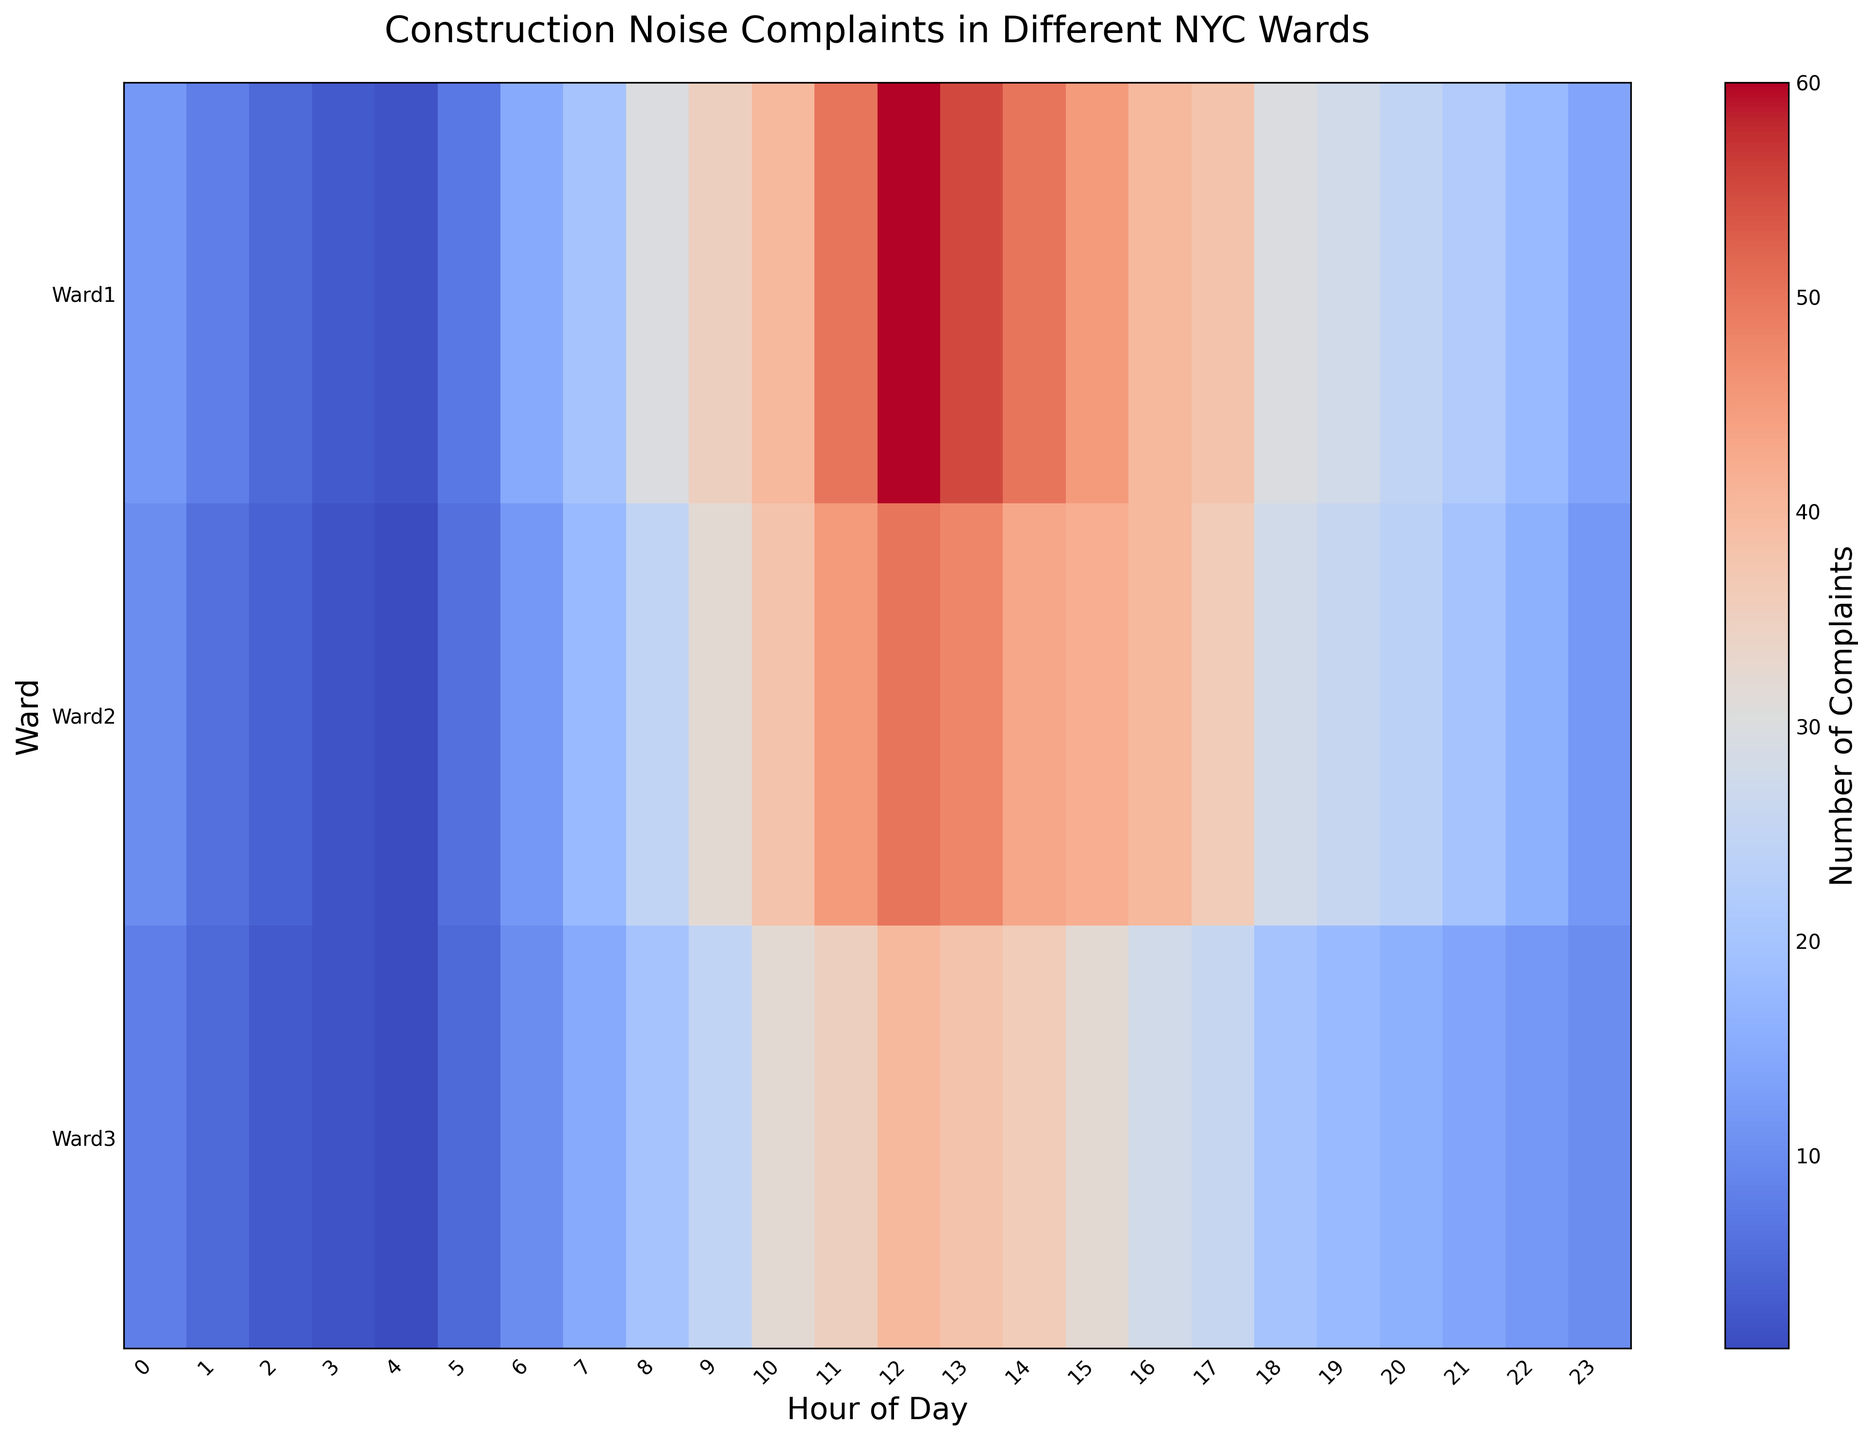What is the total number of complaints in Ward1 during the 8 AM and 9 AM hours? To get the total number of complaints, sum up the complaints at 8 AM and 9 AM for Ward1. These numbers are 30 for 8 AM and 35 for 9 AM. Adding them gives 30 + 35 = 65.
Answer: 65 At which hour does Ward2 observe the peak number of complaints? To find the peak number of complaints for Ward2, we look for the highest value on the heatmap for Ward2 across all hours. The highest complaint number is 50, which occurs at 12 PM.
Answer: 12 PM Is the number of complaints in Ward3 at 3 AM lower than the number of complaints in Ward1 at the same hour? To compare, look at the value for Ward3 at 3 AM and Ward1 at 3 AM. Ward3 has 2 complaints and Ward1 has 3 complaints at 3 AM. Since 2 is less than 3, the number of complaints in Ward3 is indeed lower.
Answer: Yes What is the difference in the number of complaints between Ward2 and Ward3 at 10 AM? To find the difference, look at the number of complaints in Ward2 and Ward3 at 10 AM. Ward2 has 38 complaints and Ward3 has 32 complaints. The difference is 38 - 32 = 6.
Answer: 6 During which hour does Ward1 experience a significant drop in complaints from one hour to the next? To identify a significant drop, compare the complaints in Ward1 hour by hour. The largest drop is from 13 PM (55 complaints) to 14 PM (50 complaints), a decrease of 5.
Answer: 13 PM to 14 PM Which ward has the highest number of complaints at 11 AM? To determine this, look at the 11 AM row for all wards. Ward1 has 50, Ward2 has 45, and Ward3 has 35 complaints. Ward1 has the highest at 50 complaints.
Answer: Ward1 What is the average number of complaints during the midnight hour (0 AM) across all wards? To find the average, sum the complaints at 0 AM for all wards and divide by the number of wards. Ward1 has 12, Ward2 has 10, and Ward3 has 8 complaints at 0 AM. The sum is 12 + 10 + 8 = 30. The average is 30 / 3 = 10.
Answer: 10 Are complaints more evenly distributed throughout the day in Ward2 compared to Ward1? To determine the distribution, observe the range of complaints over the hours for Ward2 and Ward1. Ward2 ranges from 1 to 50 complaints, whereas Ward1 ranges from 2 to 60 complaints. Ward2 has a narrower range, indicating more even distribution.
Answer: Yes How do the number of complaints at 7 AM compare across the three wards? Examine the complaints at 7 AM for each ward. Ward1 has 20, Ward2 has 18, and Ward3 has 15 complaints at 7 AM. Ward1 has the highest complaints at this hour.
Answer: Ward1 has the highest, followed by Ward2, then Ward3 Which ward has the most consistent number of complaints from 8 PM to 10 PM? To evaluate consistency, look at the complaints from 8 PM to 10 PM for each ward and observe the variation. Ward1's counts are 28, 25, 22; Ward2's are 26, 24, 20; and Ward3's are 18, 16, 14. Ward3 shows the most gradual decrease, indicating the most consistency.
Answer: Ward3 